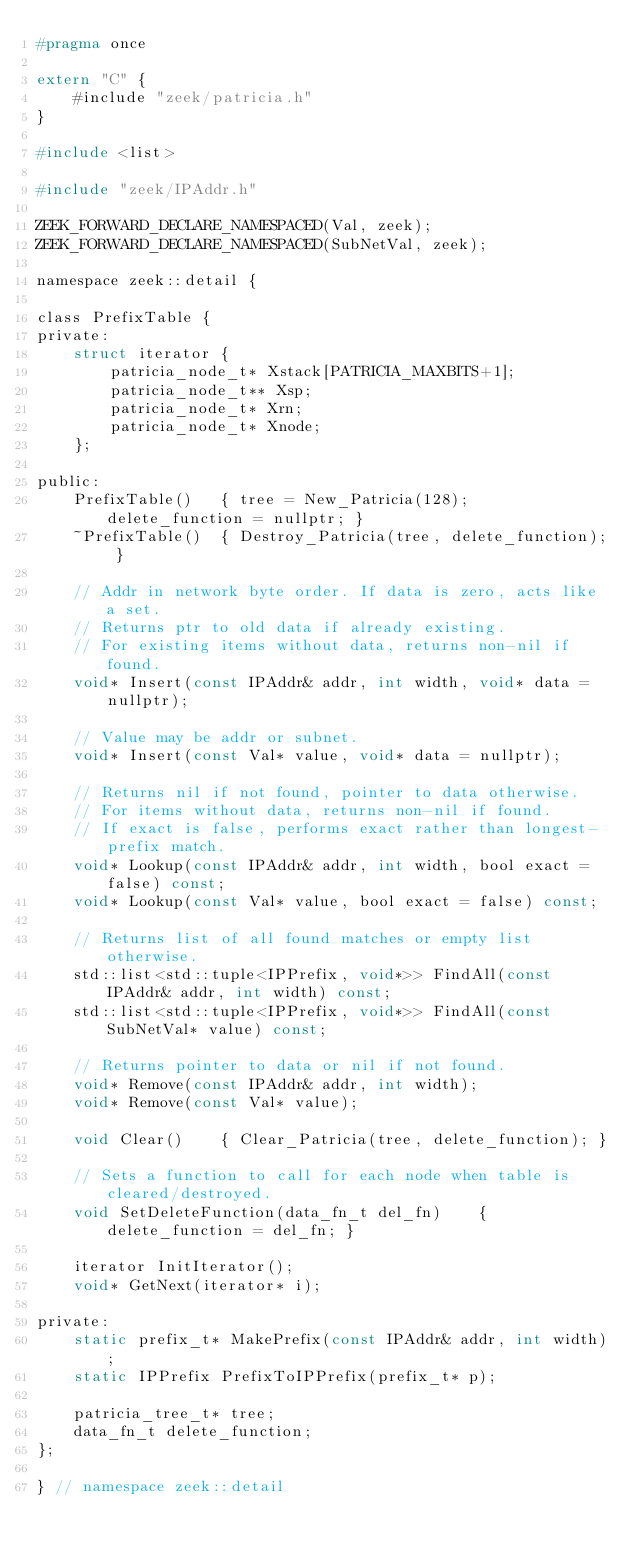<code> <loc_0><loc_0><loc_500><loc_500><_C_>#pragma once

extern "C" {
	#include "zeek/patricia.h"
}

#include <list>

#include "zeek/IPAddr.h"

ZEEK_FORWARD_DECLARE_NAMESPACED(Val, zeek);
ZEEK_FORWARD_DECLARE_NAMESPACED(SubNetVal, zeek);

namespace zeek::detail {

class PrefixTable {
private:
	struct iterator {
		patricia_node_t* Xstack[PATRICIA_MAXBITS+1];
		patricia_node_t** Xsp;
		patricia_node_t* Xrn;
		patricia_node_t* Xnode;
	};

public:
	PrefixTable()	{ tree = New_Patricia(128); delete_function = nullptr; }
	~PrefixTable()	{ Destroy_Patricia(tree, delete_function); }

	// Addr in network byte order. If data is zero, acts like a set.
	// Returns ptr to old data if already existing.
	// For existing items without data, returns non-nil if found.
	void* Insert(const IPAddr& addr, int width, void* data = nullptr);

	// Value may be addr or subnet.
	void* Insert(const Val* value, void* data = nullptr);

	// Returns nil if not found, pointer to data otherwise.
	// For items without data, returns non-nil if found.
	// If exact is false, performs exact rather than longest-prefix match.
	void* Lookup(const IPAddr& addr, int width, bool exact = false) const;
	void* Lookup(const Val* value, bool exact = false) const;

	// Returns list of all found matches or empty list otherwise.
	std::list<std::tuple<IPPrefix, void*>> FindAll(const IPAddr& addr, int width) const;
	std::list<std::tuple<IPPrefix, void*>> FindAll(const SubNetVal* value) const;

	// Returns pointer to data or nil if not found.
	void* Remove(const IPAddr& addr, int width);
	void* Remove(const Val* value);

	void Clear()	{ Clear_Patricia(tree, delete_function); }

	// Sets a function to call for each node when table is cleared/destroyed.
	void SetDeleteFunction(data_fn_t del_fn)	{ delete_function = del_fn; }

	iterator InitIterator();
	void* GetNext(iterator* i);

private:
	static prefix_t* MakePrefix(const IPAddr& addr, int width);
	static IPPrefix PrefixToIPPrefix(prefix_t* p);

	patricia_tree_t* tree;
	data_fn_t delete_function;
};

} // namespace zeek::detail
</code> 